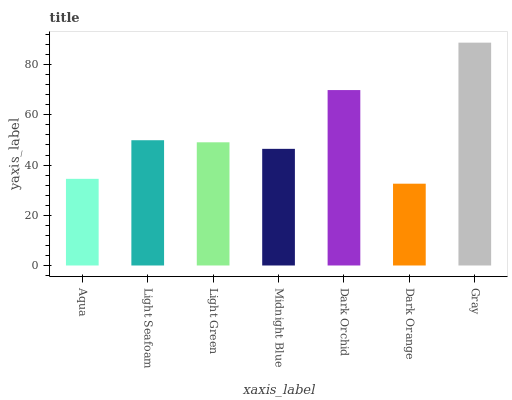Is Light Seafoam the minimum?
Answer yes or no. No. Is Light Seafoam the maximum?
Answer yes or no. No. Is Light Seafoam greater than Aqua?
Answer yes or no. Yes. Is Aqua less than Light Seafoam?
Answer yes or no. Yes. Is Aqua greater than Light Seafoam?
Answer yes or no. No. Is Light Seafoam less than Aqua?
Answer yes or no. No. Is Light Green the high median?
Answer yes or no. Yes. Is Light Green the low median?
Answer yes or no. Yes. Is Light Seafoam the high median?
Answer yes or no. No. Is Midnight Blue the low median?
Answer yes or no. No. 